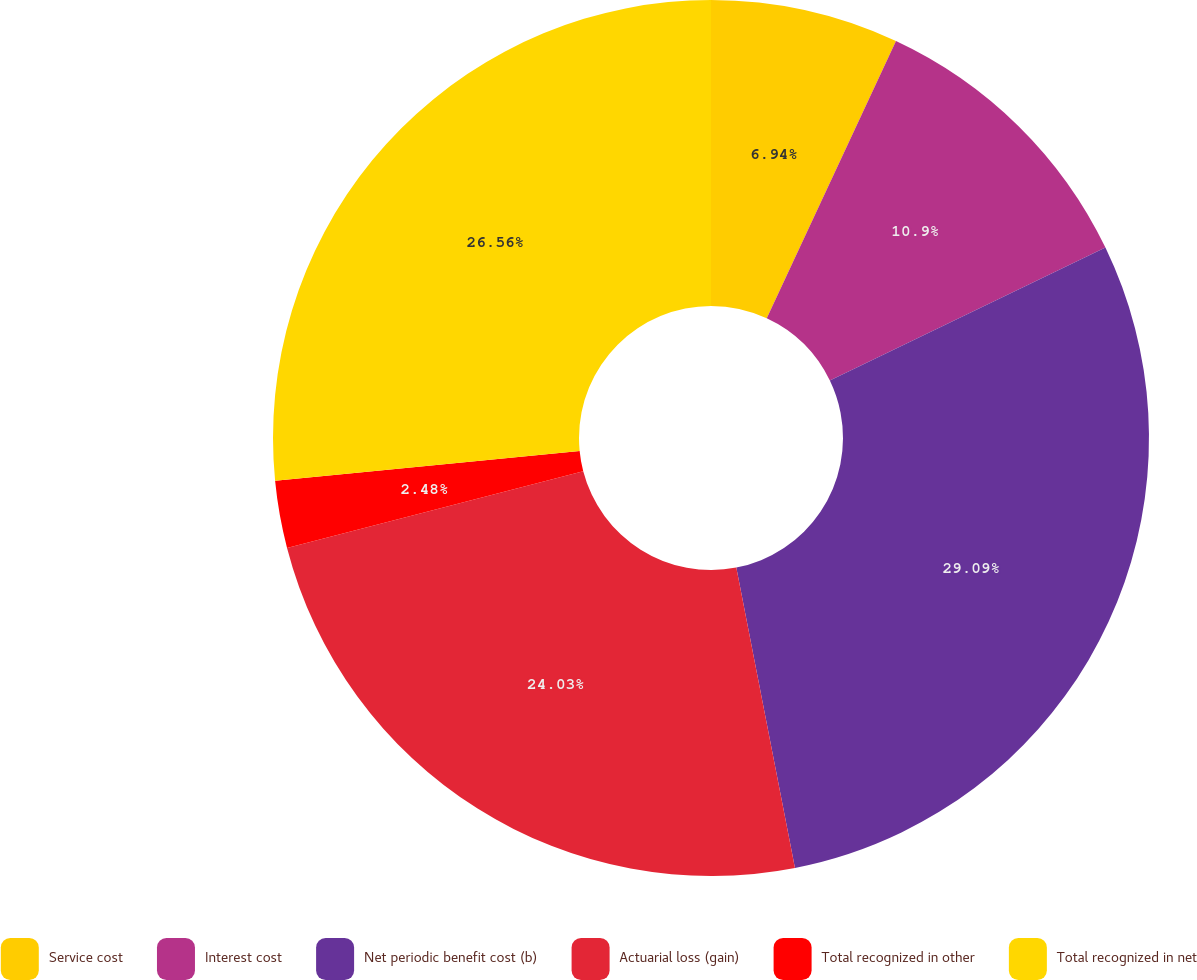Convert chart. <chart><loc_0><loc_0><loc_500><loc_500><pie_chart><fcel>Service cost<fcel>Interest cost<fcel>Net periodic benefit cost (b)<fcel>Actuarial loss (gain)<fcel>Total recognized in other<fcel>Total recognized in net<nl><fcel>6.94%<fcel>10.9%<fcel>29.09%<fcel>24.03%<fcel>2.48%<fcel>26.56%<nl></chart> 